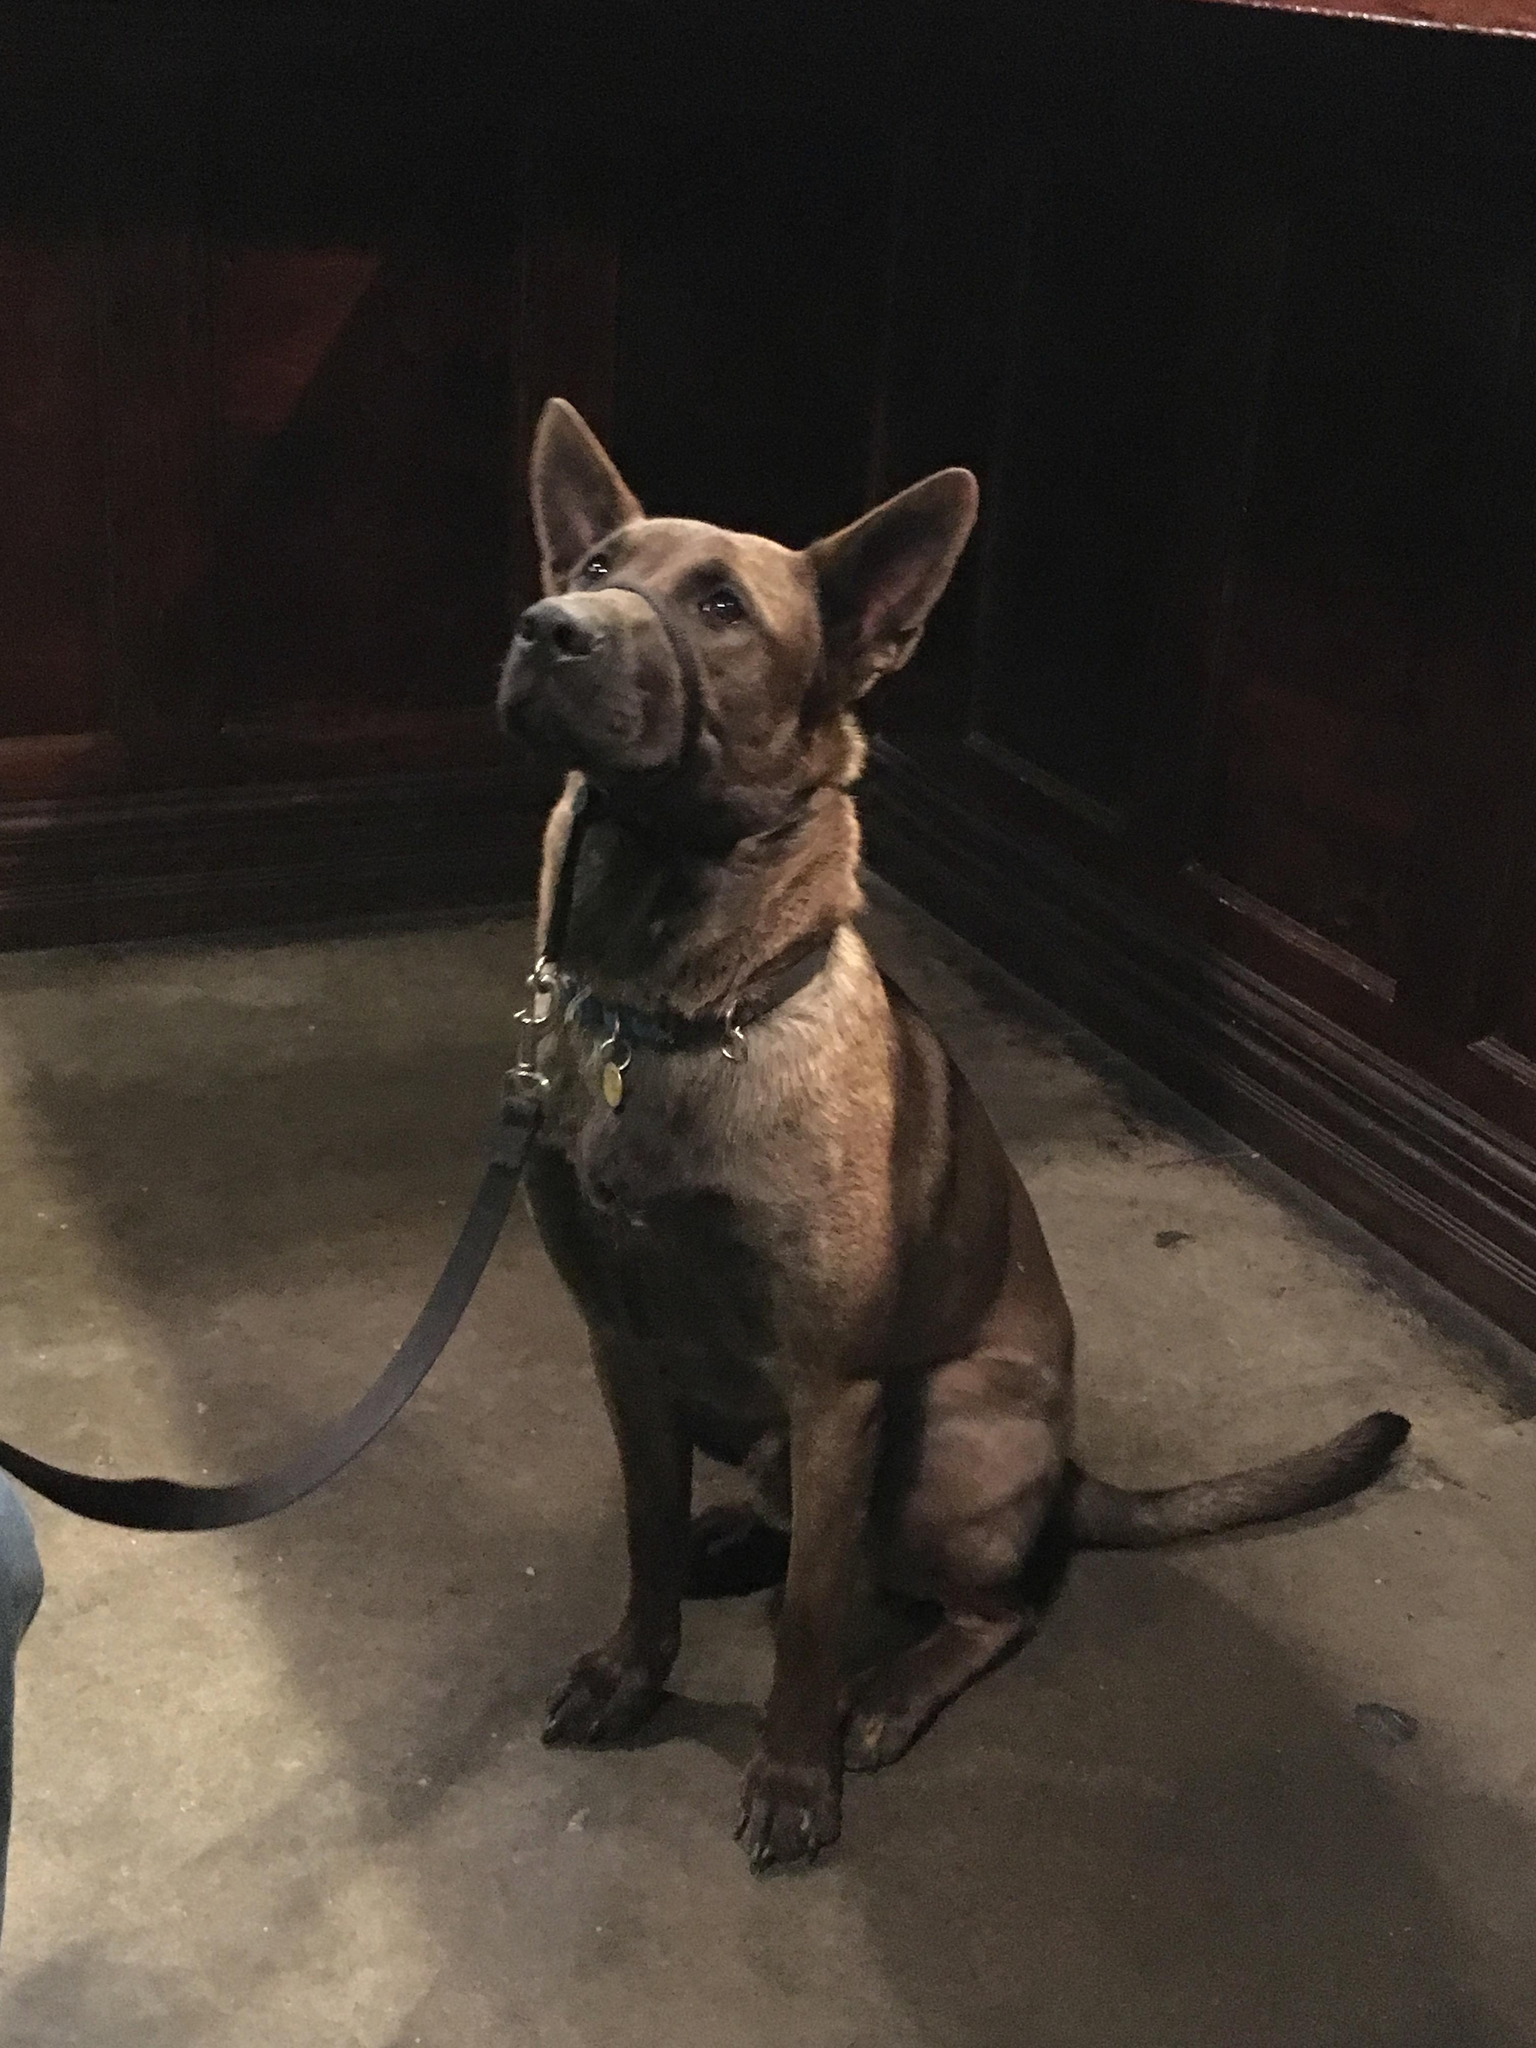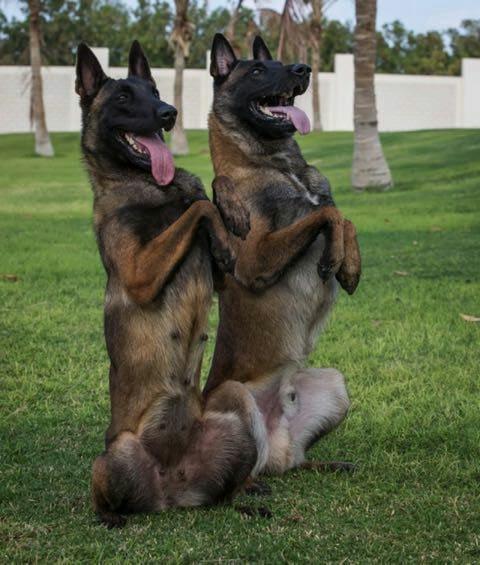The first image is the image on the left, the second image is the image on the right. Given the left and right images, does the statement "An image shows an arm extending something to a german shepherd on a leash." hold true? Answer yes or no. No. The first image is the image on the left, the second image is the image on the right. Assess this claim about the two images: "One of the images contains more than one dog.". Correct or not? Answer yes or no. Yes. 